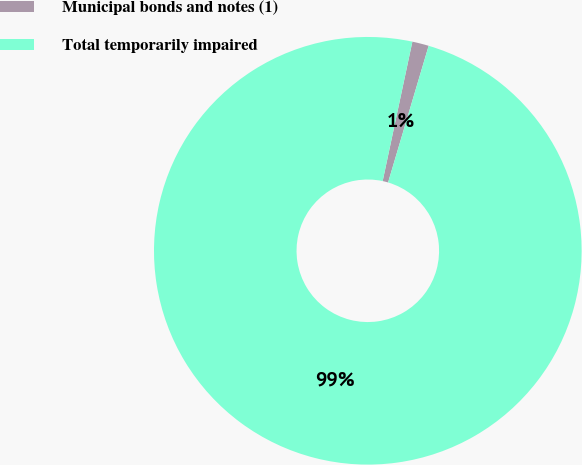<chart> <loc_0><loc_0><loc_500><loc_500><pie_chart><fcel>Municipal bonds and notes (1)<fcel>Total temporarily impaired<nl><fcel>1.25%<fcel>98.75%<nl></chart> 